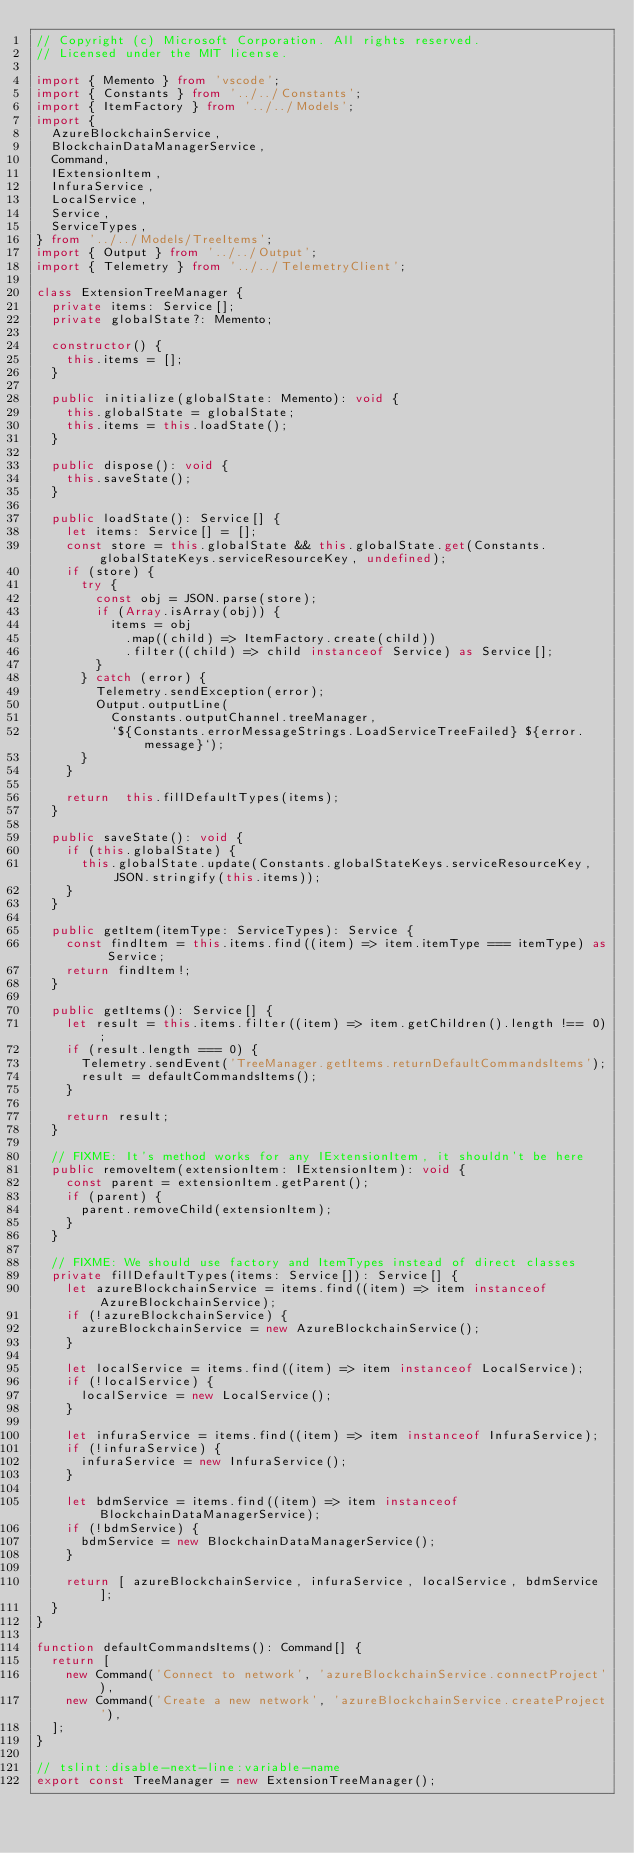<code> <loc_0><loc_0><loc_500><loc_500><_TypeScript_>// Copyright (c) Microsoft Corporation. All rights reserved.
// Licensed under the MIT license.

import { Memento } from 'vscode';
import { Constants } from '../../Constants';
import { ItemFactory } from '../../Models';
import {
  AzureBlockchainService,
  BlockchainDataManagerService,
  Command,
  IExtensionItem,
  InfuraService,
  LocalService,
  Service,
  ServiceTypes,
} from '../../Models/TreeItems';
import { Output } from '../../Output';
import { Telemetry } from '../../TelemetryClient';

class ExtensionTreeManager {
  private items: Service[];
  private globalState?: Memento;

  constructor() {
    this.items = [];
  }

  public initialize(globalState: Memento): void {
    this.globalState = globalState;
    this.items = this.loadState();
  }

  public dispose(): void {
    this.saveState();
  }

  public loadState(): Service[] {
    let items: Service[] = [];
    const store = this.globalState && this.globalState.get(Constants.globalStateKeys.serviceResourceKey, undefined);
    if (store) {
      try {
        const obj = JSON.parse(store);
        if (Array.isArray(obj)) {
          items = obj
            .map((child) => ItemFactory.create(child))
            .filter((child) => child instanceof Service) as Service[];
        }
      } catch (error) {
        Telemetry.sendException(error);
        Output.outputLine(
          Constants.outputChannel.treeManager,
          `${Constants.errorMessageStrings.LoadServiceTreeFailed} ${error.message}`);
      }
    }

    return  this.fillDefaultTypes(items);
  }

  public saveState(): void {
    if (this.globalState) {
      this.globalState.update(Constants.globalStateKeys.serviceResourceKey, JSON.stringify(this.items));
    }
  }

  public getItem(itemType: ServiceTypes): Service {
    const findItem = this.items.find((item) => item.itemType === itemType) as Service;
    return findItem!;
  }

  public getItems(): Service[] {
    let result = this.items.filter((item) => item.getChildren().length !== 0);
    if (result.length === 0) {
      Telemetry.sendEvent('TreeManager.getItems.returnDefaultCommandsItems');
      result = defaultCommandsItems();
    }

    return result;
  }

  // FIXME: It's method works for any IExtensionItem, it shouldn't be here
  public removeItem(extensionItem: IExtensionItem): void {
    const parent = extensionItem.getParent();
    if (parent) {
      parent.removeChild(extensionItem);
    }
  }

  // FIXME: We should use factory and ItemTypes instead of direct classes
  private fillDefaultTypes(items: Service[]): Service[] {
    let azureBlockchainService = items.find((item) => item instanceof AzureBlockchainService);
    if (!azureBlockchainService) {
      azureBlockchainService = new AzureBlockchainService();
    }

    let localService = items.find((item) => item instanceof LocalService);
    if (!localService) {
      localService = new LocalService();
    }

    let infuraService = items.find((item) => item instanceof InfuraService);
    if (!infuraService) {
      infuraService = new InfuraService();
    }

    let bdmService = items.find((item) => item instanceof BlockchainDataManagerService);
    if (!bdmService) {
      bdmService = new BlockchainDataManagerService();
    }

    return [ azureBlockchainService, infuraService, localService, bdmService];
  }
}

function defaultCommandsItems(): Command[] {
  return [
    new Command('Connect to network', 'azureBlockchainService.connectProject'),
    new Command('Create a new network', 'azureBlockchainService.createProject'),
  ];
}

// tslint:disable-next-line:variable-name
export const TreeManager = new ExtensionTreeManager();
</code> 